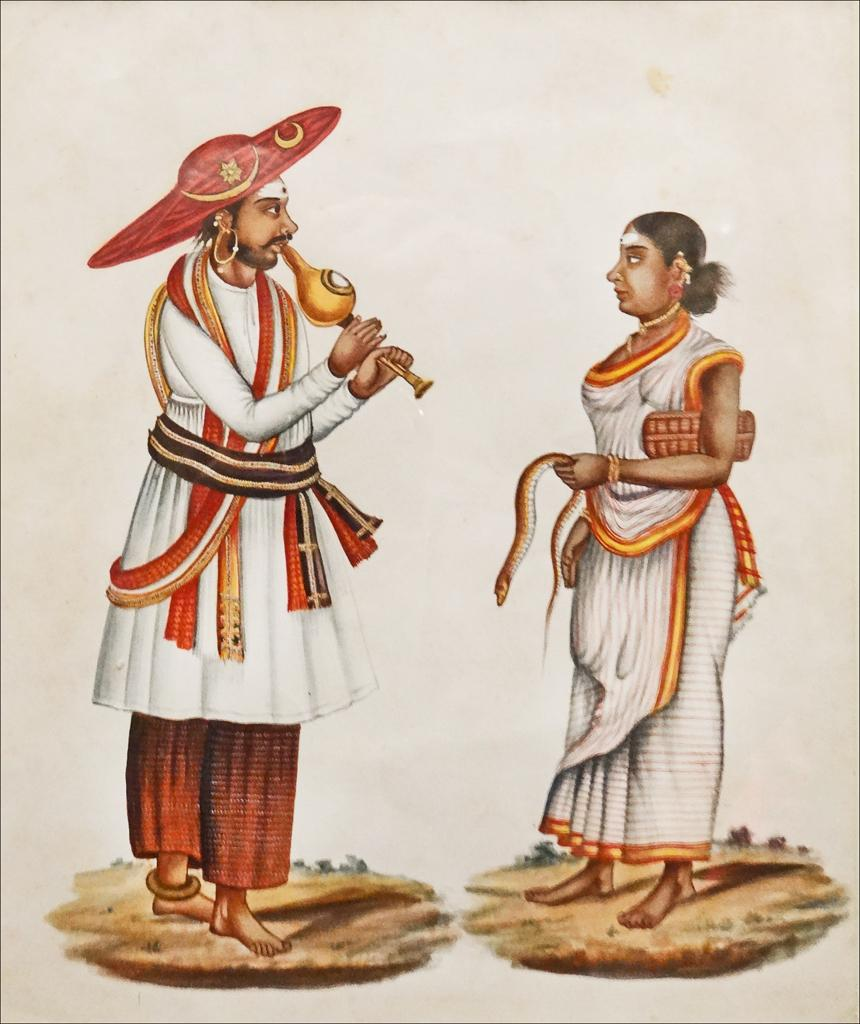How many people are in the image? There are two persons in the image. What is one person wearing? One person is wearing a cap. What is the person wearing a cap holding? The person wearing a cap is holding a musical instrument. What is the woman holding in her hand? The woman is holding a snake in her hand. What type of house can be seen in the background of the image? There is no house visible in the background of the image. What kind of fowl is present in the image? There are no fowl present in the image; it features two people, one of whom is holding a musical instrument and the other holding a snake. 